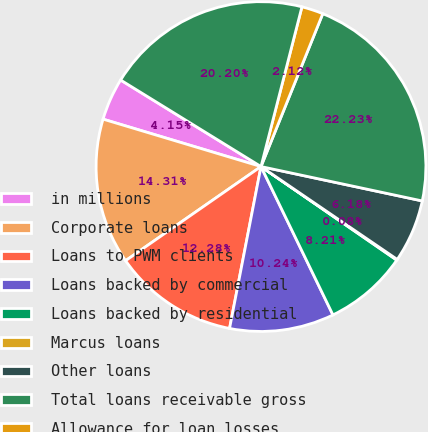<chart> <loc_0><loc_0><loc_500><loc_500><pie_chart><fcel>in millions<fcel>Corporate loans<fcel>Loans to PWM clients<fcel>Loans backed by commercial<fcel>Loans backed by residential<fcel>Marcus loans<fcel>Other loans<fcel>Total loans receivable gross<fcel>Allowance for loan losses<fcel>Total loans receivable<nl><fcel>4.15%<fcel>14.31%<fcel>12.28%<fcel>10.24%<fcel>8.21%<fcel>0.08%<fcel>6.18%<fcel>22.23%<fcel>2.12%<fcel>20.2%<nl></chart> 